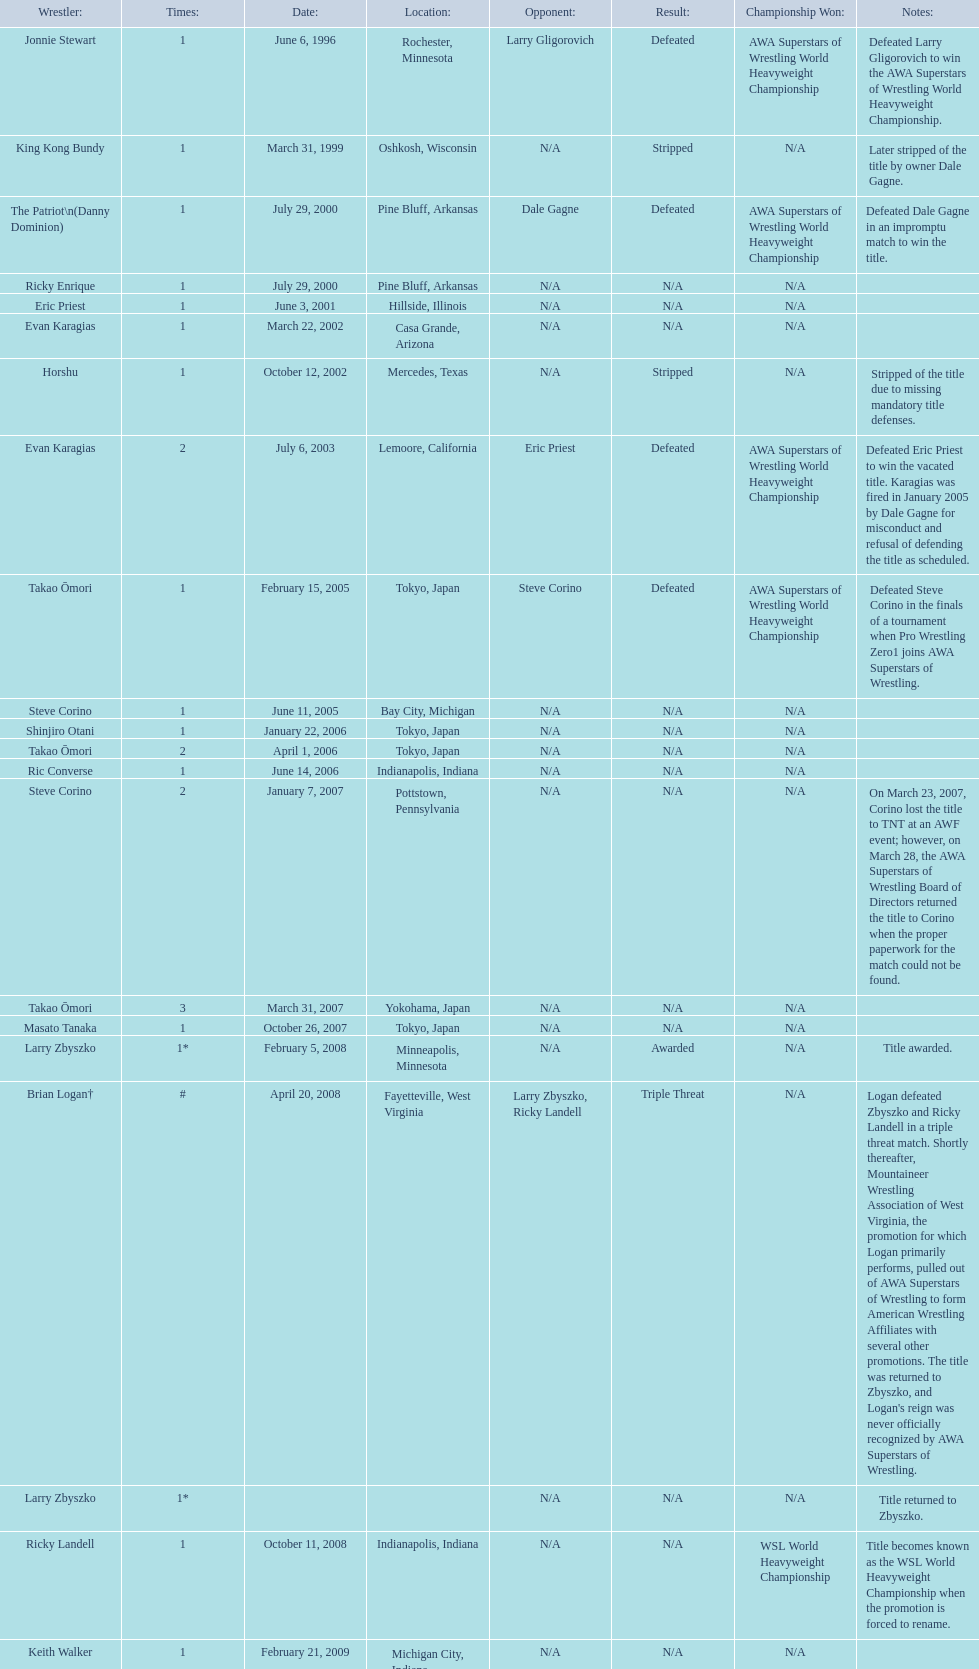Who is the only wsl title holder from texas? Horshu. 